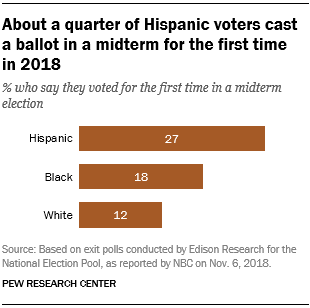Identify some key points in this picture. The value of the middle bar is 18. The product of the median value and largest value in the graph is 486. 